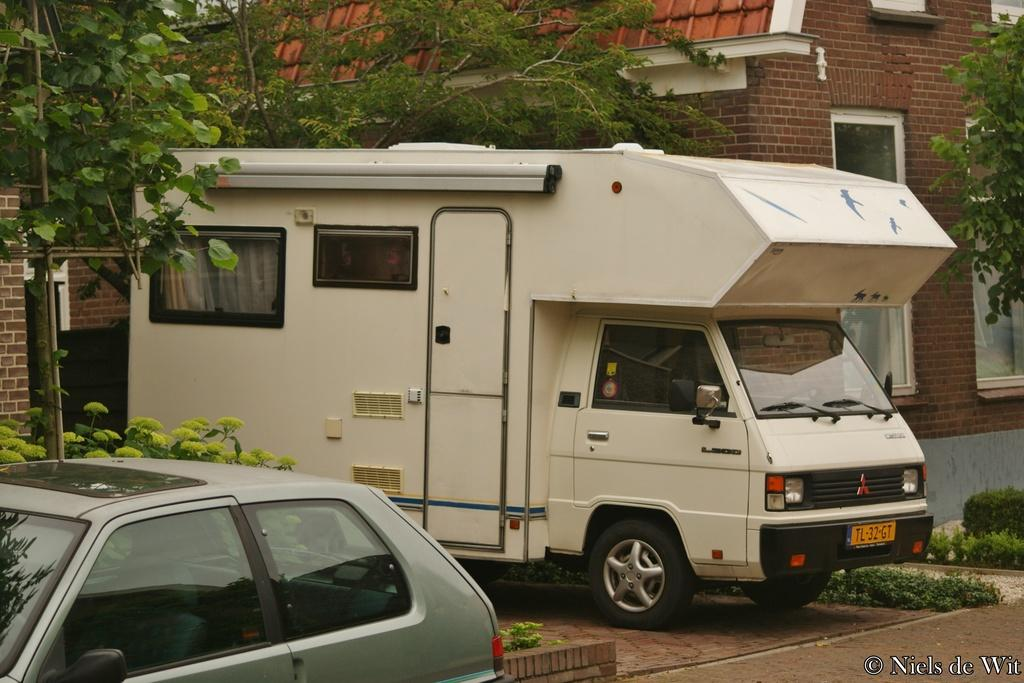What types of objects are on the ground in the image? There are vehicles on the ground in the image. What other elements can be seen in the image besides the vehicles? There are plants and trees in the image. What is visible in the background of the image? There is a building in the background of the image. What type of lead can be seen in the image? There is no lead present in the image. How does the digestion process of the plants in the image work? The image does not provide information about the digestion process of the plants. 